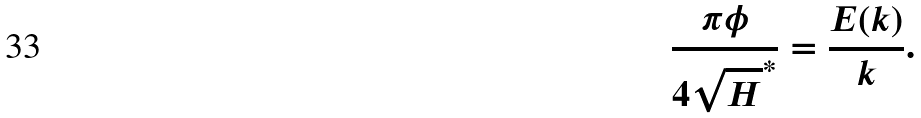Convert formula to latex. <formula><loc_0><loc_0><loc_500><loc_500>\frac { \pi \phi } { 4 \sqrt { H } ^ { \ast } } = \frac { E ( k ) } { k } .</formula> 